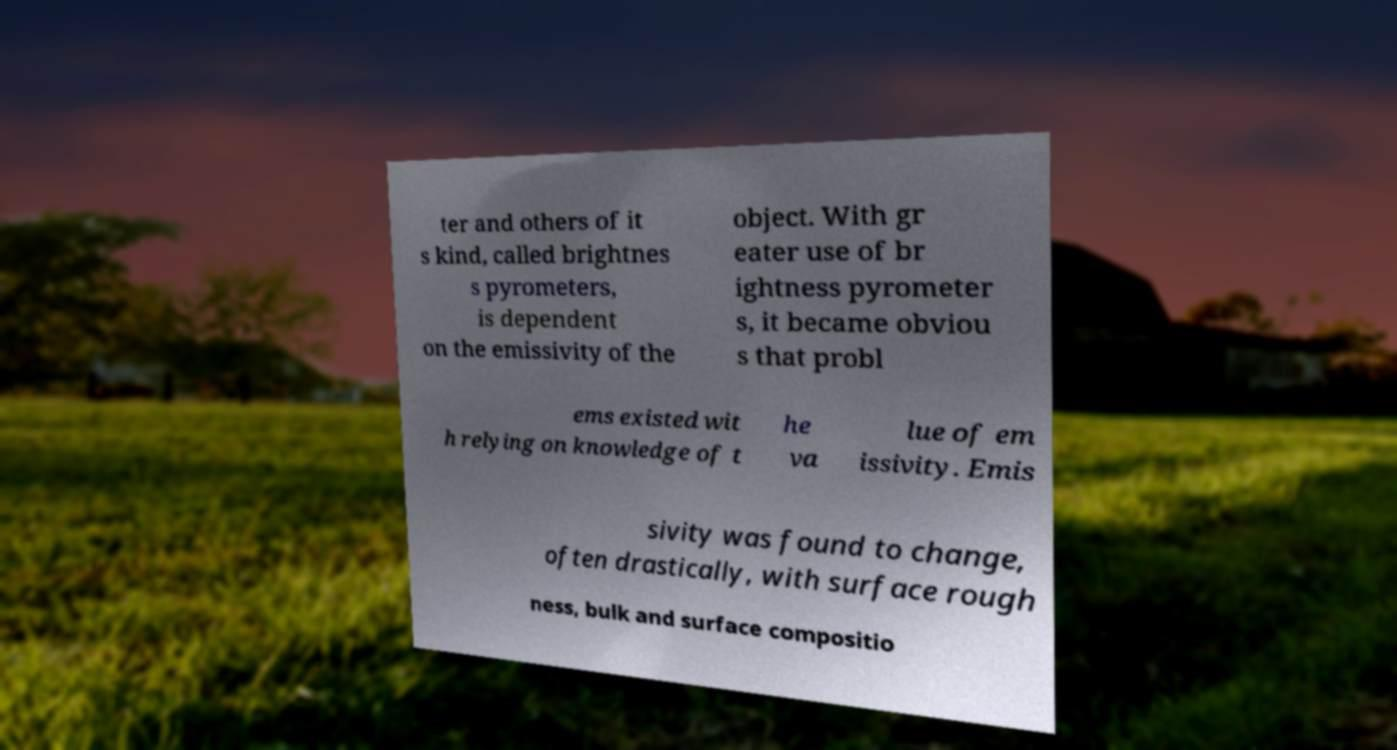For documentation purposes, I need the text within this image transcribed. Could you provide that? ter and others of it s kind, called brightnes s pyrometers, is dependent on the emissivity of the object. With gr eater use of br ightness pyrometer s, it became obviou s that probl ems existed wit h relying on knowledge of t he va lue of em issivity. Emis sivity was found to change, often drastically, with surface rough ness, bulk and surface compositio 